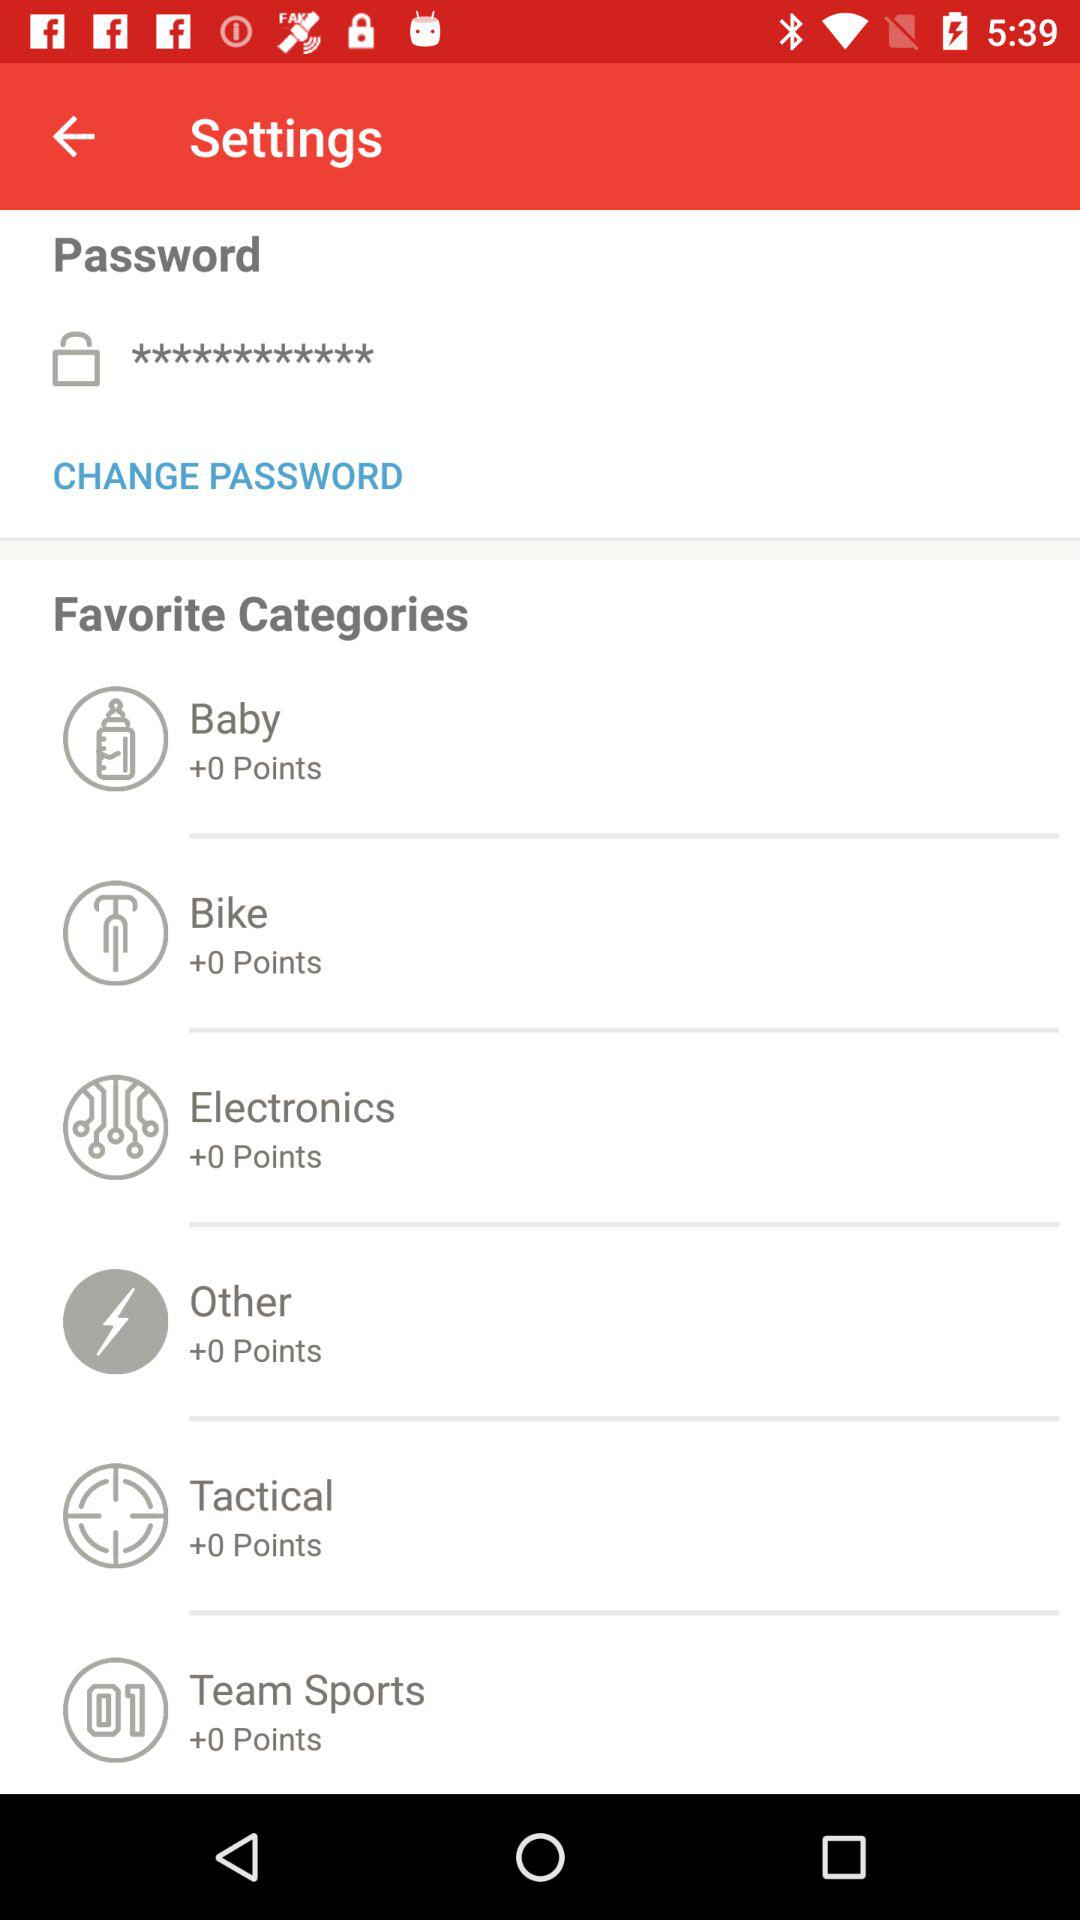What are the points in "Bike"? The points in "Bike" are 0. 